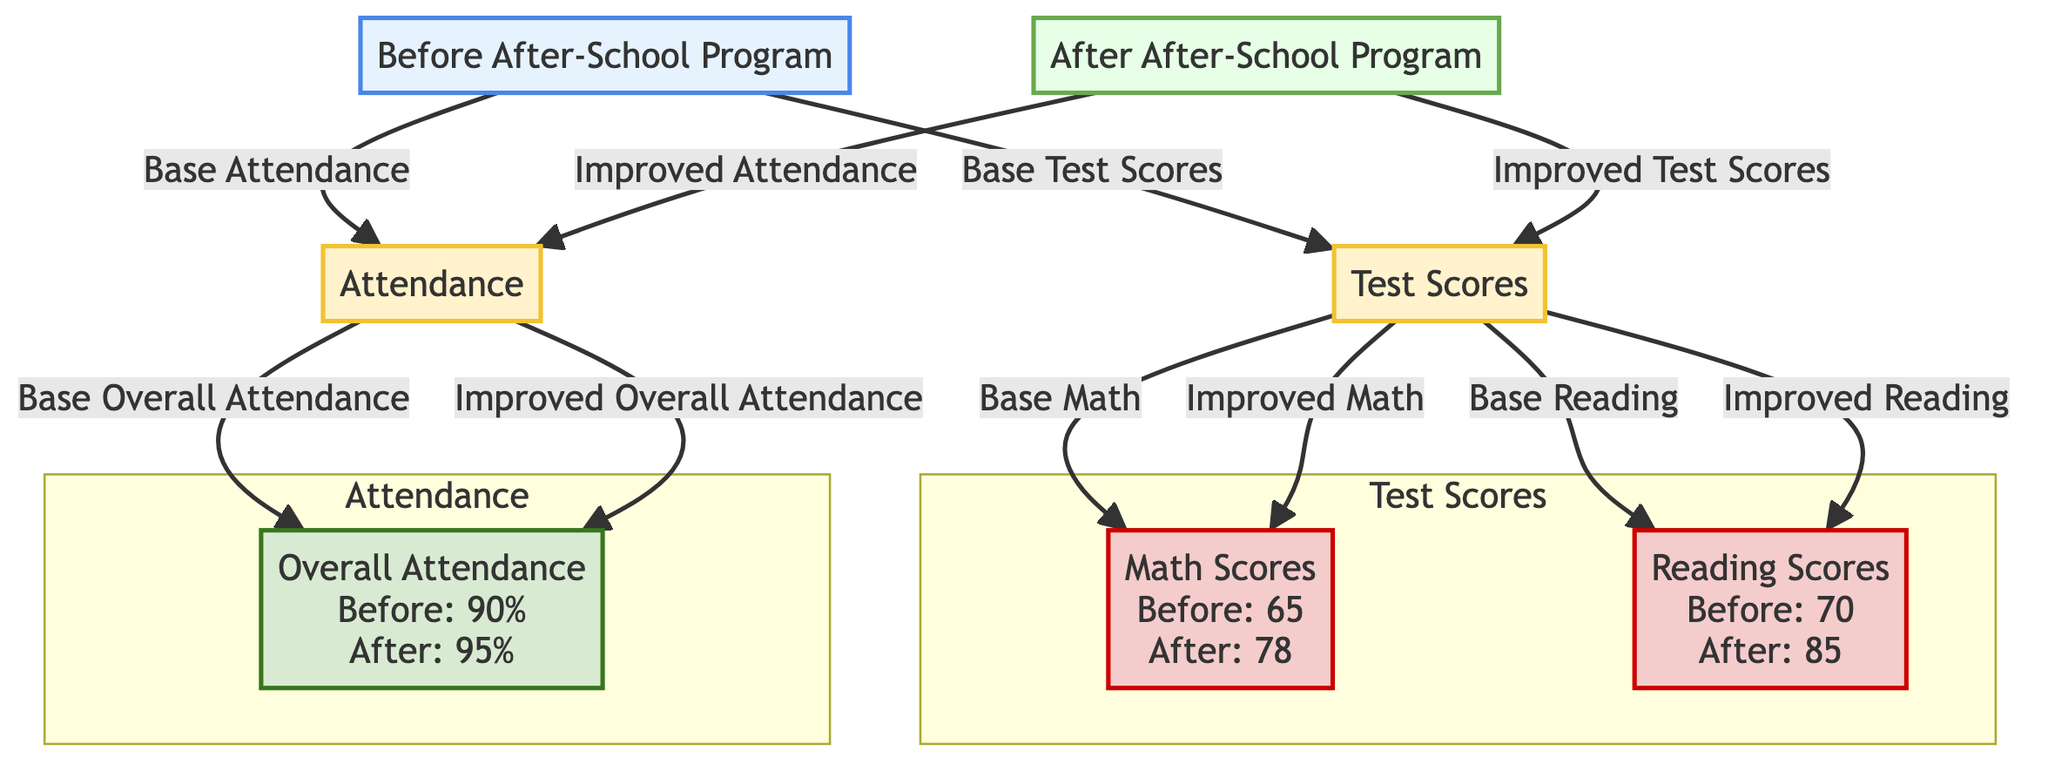What were the Math Scores before the program? The diagram shows that the Math Scores before the after-school program were 65.
Answer: 65 What improvement was seen in Reading Scores? The diagram provides the values of Reading Scores before and after the program; it was 70 before and improved to 85 after, indicating an improvement of 15 points.
Answer: 15 points What was the attendance rate before the after-school program? By examining the node labeled "Overall Attendance" in the "Before After-School Program" section, it states that the attendance rate was 90%.
Answer: 90% How much did the Math Scores increase after the program? The Math Scores were 65 before and increased to 78 after the program. The increase can be calculated as 78 - 65 = 13.
Answer: 13 Which metric saw the highest score after the program? The Reading Scores after the program were at 85, which is the highest score compared to Math Scores at 78 and Overall Attendance at 95%.
Answer: Reading Scores What percentage increase was seen in overall attendance? Overall attendance increased from 90% to 95%, representing a change of 5%. To find the percentage increase, calculate (95 - 90) / 90 * 100 = 5.56%.
Answer: 5.56% How many total scores are indicated in the "Test Scores" section? The "Test Scores" section includes Math Scores and Reading Scores. Therefore, there are two distinct scores indicated here.
Answer: 2 What was the change in Math Scores from before to after the program? The diagram reflects a shift in Math Scores from 65 before to 78 after the program, demonstrating a clear positive change of 13 points.
Answer: 13 points What is the relationship between Attendance and Test Scores in the diagram? The diagram illustrates that both metrics, Attendance and Test Scores, are linked to the state before and after the after-school program. Attendance leads to Overall Attendance while Test Scores lead to Math and Reading Scores.
Answer: Linked 